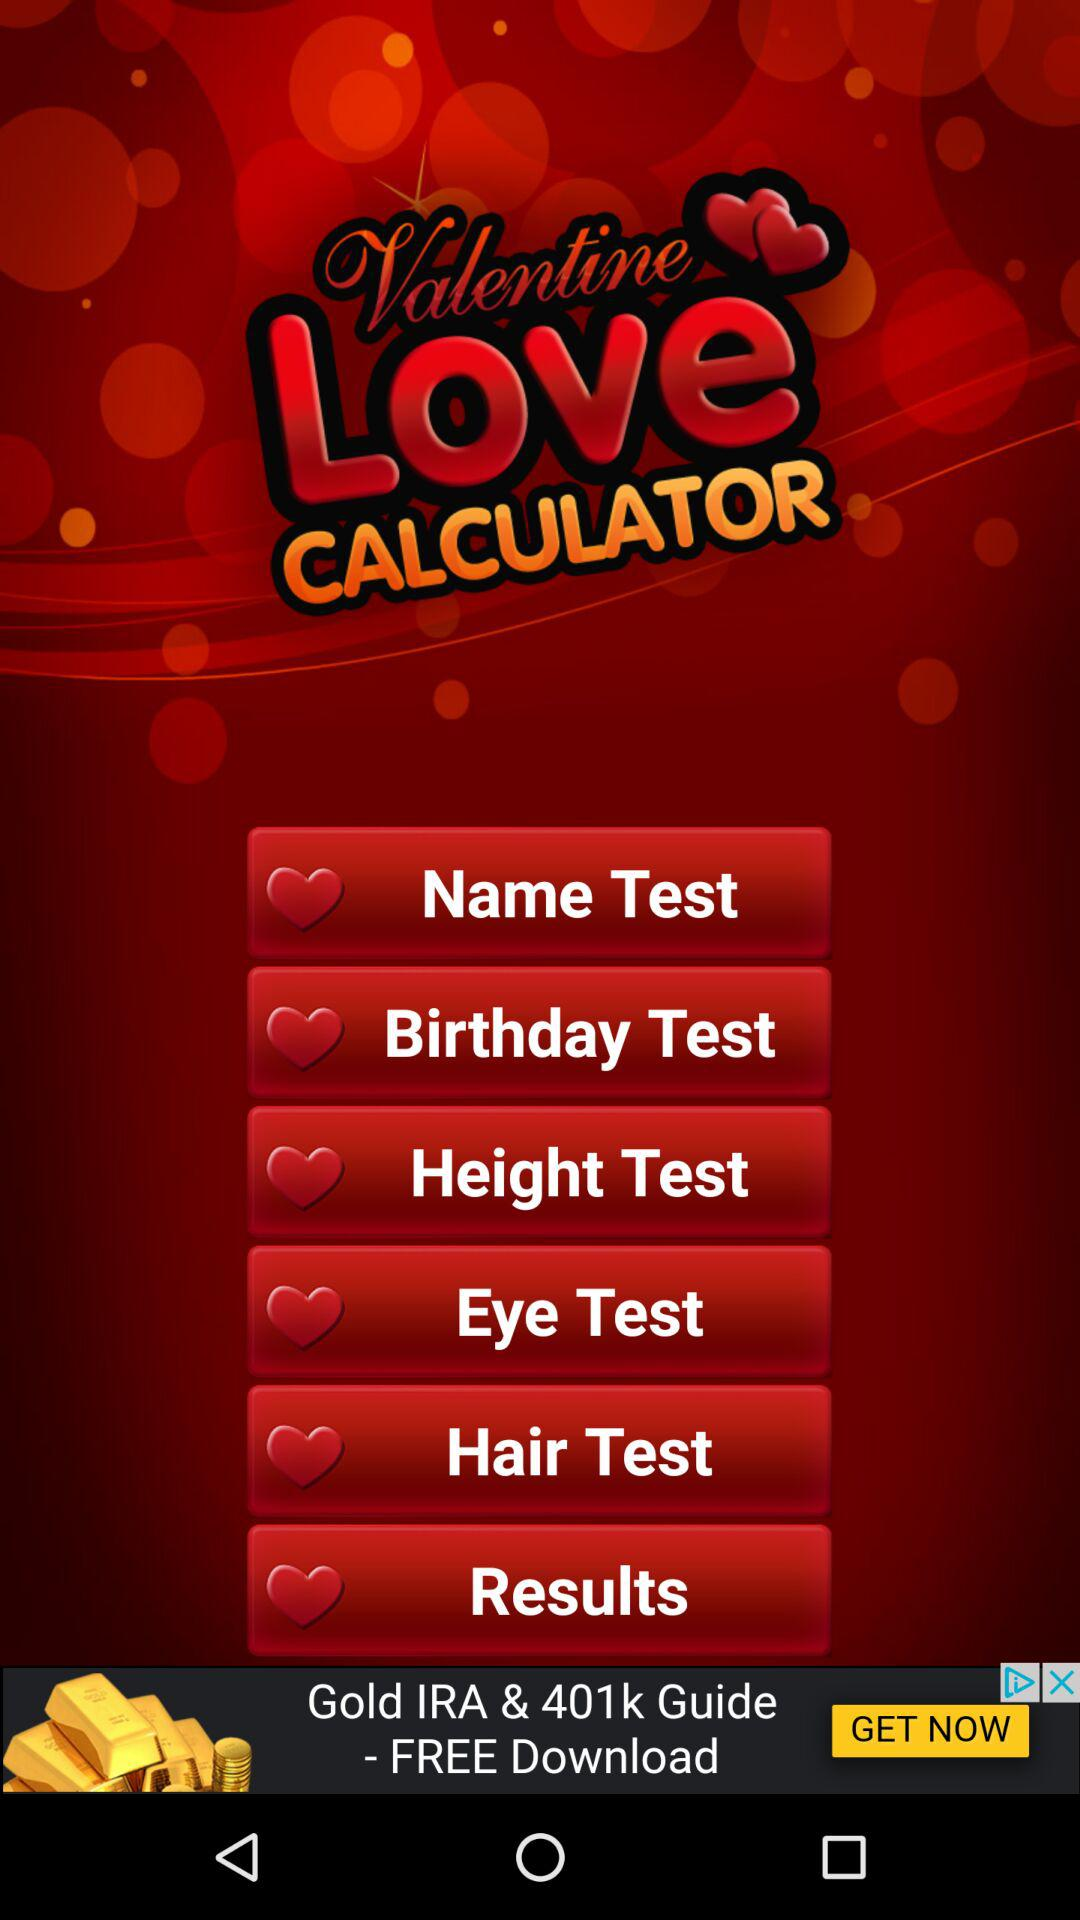How many tests are there to take?
Answer the question using a single word or phrase. 6 